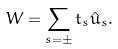<formula> <loc_0><loc_0><loc_500><loc_500>W = \sum _ { s = \pm } t _ { s } \hat { u } _ { s } .</formula> 